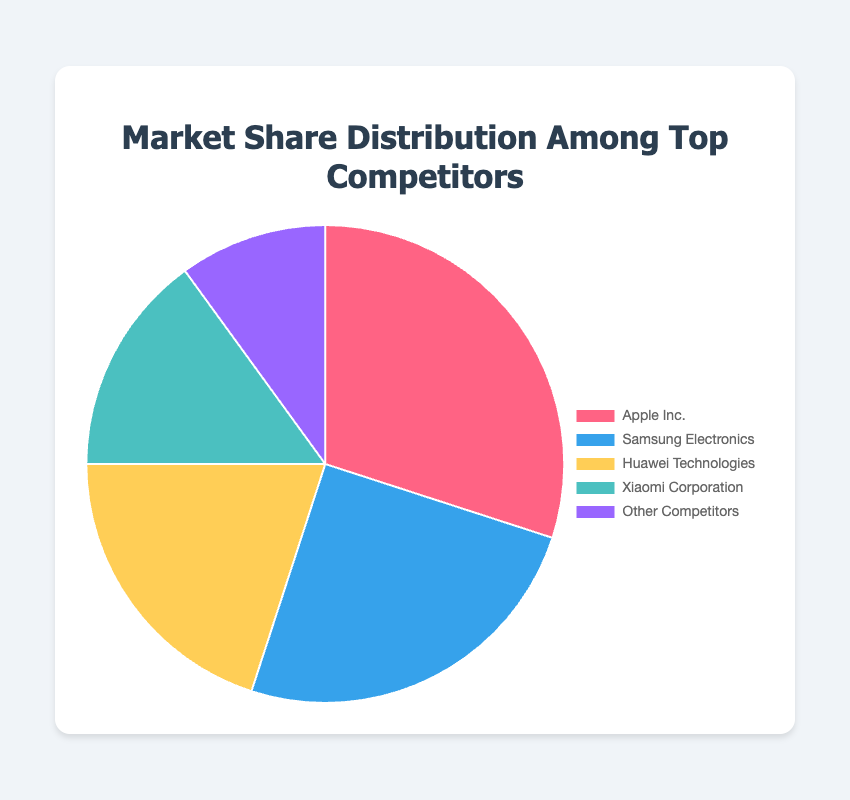Which company has the highest market share percentage? The figure shows the market share distribution. By looking at the data, we see that Apple Inc. has the highest market share percentage.
Answer: Apple Inc Which two companies combined have a market share of 50%? Adding the market shares of Samsung Electronics (25%) and Huawei Technologies (20%) results in 45%, which is less than 50%. Adding the market shares of Apple Inc. (30%) and Samsung Electronics (25%) results in 55%, which is closest to 50% but over. Therefore, no exact match, but Apple Inc. (30%) and Xiaomi Corporation (15%) combined is 45%.
Answer: Apple Inc. and Samsung Electronics What is the difference in market share between Apple Inc. and Huawei Technologies? Subtract the market share of Huawei Technologies (20%) from that of Apple Inc. (30%) to get the difference: 30% - 20% = 10%.
Answer: 10% What percentage of the market share is held by companies other than the top four competitors? The data indicates that 'Other Competitors' hold a market share of 10%.
Answer: 10% Which company has the smallest market share, and what is its value? By looking at the data distribution, Xiaomi Corporation has the smallest market share among the top four competitors, with 15%.
Answer: Xiaomi Corporation, 15% How much more market share does Samsung Electronics have than Xiaomi Corporation? Subtract the market share percentage of Xiaomi Corporation (15%) from that of Samsung Electronics (25%): 25% - 15% = 10%.
Answer: 10% What is the combined market share percentage of companies with more than 20% market share each? Apple Inc. (30%) and Samsung Electronics (25%) each have more than 20% market share. Adding these together: 30% + 25% = 55%.
Answer: 55% Is any company’s market share exactly double that of any other company? Comparing the percentages, Apple Inc.'s 30% is not double Samsung's 25% or Huawei's 20%. No company's market share is exactly double another.
Answer: No What portion of the pie chart is represented by companies with less than 20% market share? Adding the market shares of Xiaomi Corporation (15%) and 'Other Competitors' (10%): 15% + 10% = 25%.
Answer: 25% What is the average market share of the top four competitors? Adding the market share percentages of Apple Inc. (30%), Samsung Electronics (25%), Huawei Technologies (20%), and Xiaomi Corporation (15%) gives a sum of 90%. Dividing this sum by 4 results in the average: 90% / 4 = 22.5%.
Answer: 22.5% 